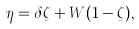Convert formula to latex. <formula><loc_0><loc_0><loc_500><loc_500>\eta = \delta \zeta + W ( 1 - \zeta ) ,</formula> 